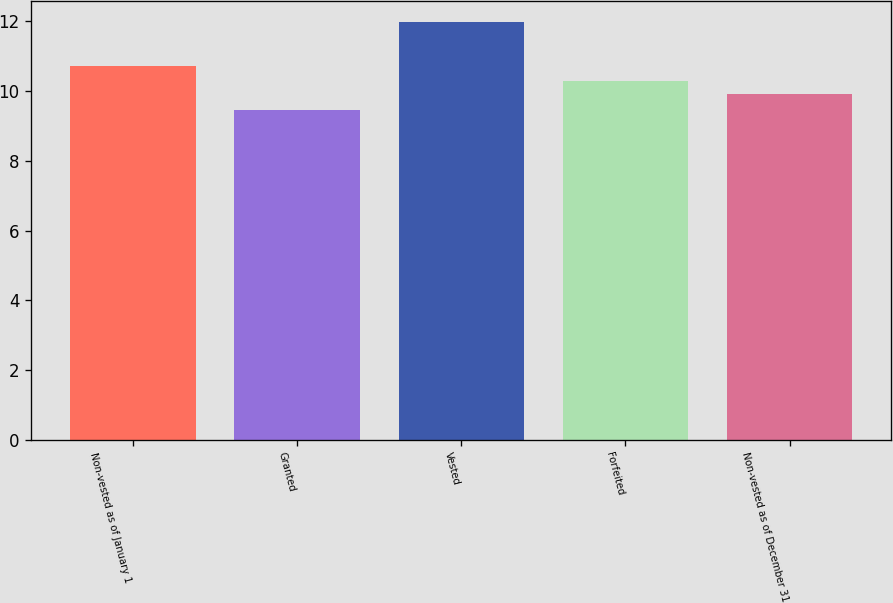Convert chart to OTSL. <chart><loc_0><loc_0><loc_500><loc_500><bar_chart><fcel>Non-vested as of January 1<fcel>Granted<fcel>Vested<fcel>Forfeited<fcel>Non-vested as of December 31<nl><fcel>10.73<fcel>9.46<fcel>11.98<fcel>10.3<fcel>9.92<nl></chart> 